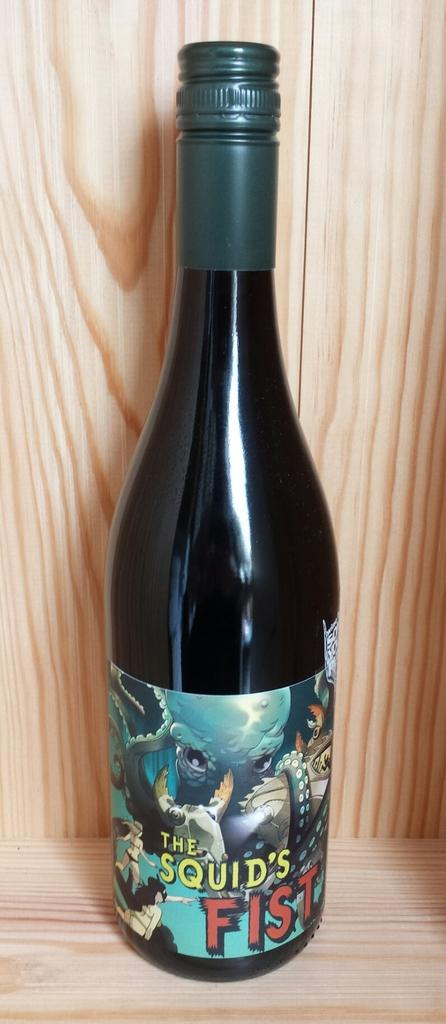Provide a one-sentence caption for the provided image. A tall bottle of The Squid's Fist wine on a wooden shelf. 